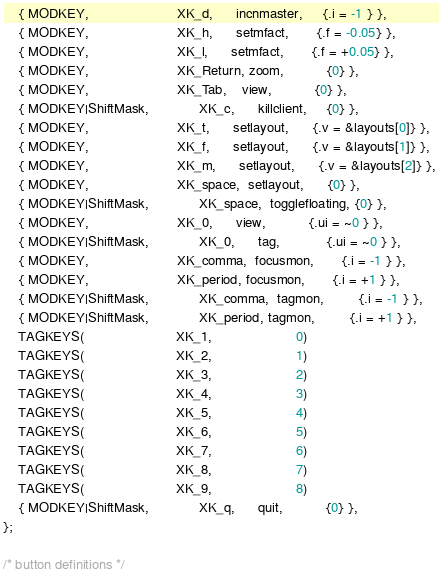<code> <loc_0><loc_0><loc_500><loc_500><_C_>	{ MODKEY,                       XK_d,      incnmaster,     {.i = -1 } },
	{ MODKEY,                       XK_h,      setmfact,       {.f = -0.05} },
	{ MODKEY,                       XK_l,      setmfact,       {.f = +0.05} },
	{ MODKEY,                       XK_Return, zoom,           {0} },
	{ MODKEY,                       XK_Tab,    view,           {0} },
	{ MODKEY|ShiftMask,             XK_c,      killclient,     {0} },
	{ MODKEY,                       XK_t,      setlayout,      {.v = &layouts[0]} },
	{ MODKEY,                       XK_f,      setlayout,      {.v = &layouts[1]} },
	{ MODKEY,                       XK_m,      setlayout,      {.v = &layouts[2]} },
	{ MODKEY,                       XK_space,  setlayout,      {0} },
	{ MODKEY|ShiftMask,             XK_space,  togglefloating, {0} },
	{ MODKEY,                       XK_0,      view,           {.ui = ~0 } },
	{ MODKEY|ShiftMask,             XK_0,      tag,            {.ui = ~0 } },
	{ MODKEY,                       XK_comma,  focusmon,       {.i = -1 } },
	{ MODKEY,                       XK_period, focusmon,       {.i = +1 } },
	{ MODKEY|ShiftMask,             XK_comma,  tagmon,         {.i = -1 } },
	{ MODKEY|ShiftMask,             XK_period, tagmon,         {.i = +1 } },
	TAGKEYS(                        XK_1,                      0)
	TAGKEYS(                        XK_2,                      1)
	TAGKEYS(                        XK_3,                      2)
	TAGKEYS(                        XK_4,                      3)
	TAGKEYS(                        XK_5,                      4)
	TAGKEYS(                        XK_6,                      5)
	TAGKEYS(                        XK_7,                      6)
	TAGKEYS(                        XK_8,                      7)
	TAGKEYS(                        XK_9,                      8)
	{ MODKEY|ShiftMask,             XK_q,      quit,           {0} },
};

/* button definitions */</code> 